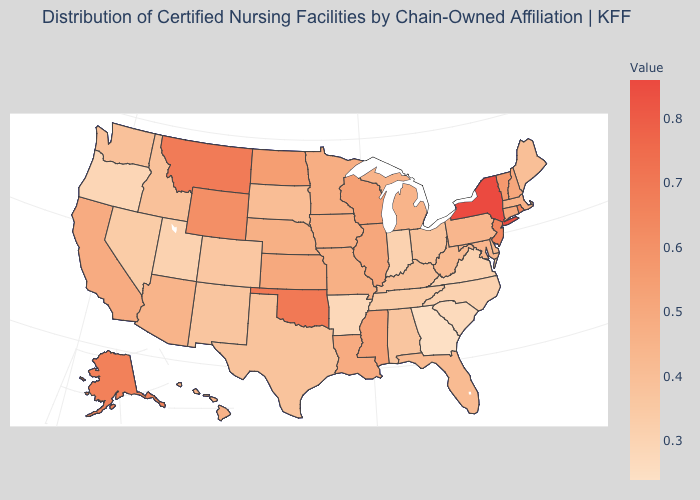Among the states that border Oklahoma , does Kansas have the highest value?
Answer briefly. Yes. Among the states that border Arizona , does California have the highest value?
Keep it brief. Yes. Among the states that border Illinois , does Wisconsin have the highest value?
Concise answer only. Yes. Among the states that border Kentucky , does Illinois have the highest value?
Give a very brief answer. Yes. Which states have the lowest value in the South?
Quick response, please. Georgia. Does the map have missing data?
Give a very brief answer. No. Does New York have the highest value in the Northeast?
Quick response, please. Yes. Which states have the lowest value in the MidWest?
Write a very short answer. Indiana. Among the states that border Wisconsin , which have the highest value?
Be succinct. Illinois. Does New York have the highest value in the USA?
Keep it brief. Yes. Does Georgia have the lowest value in the South?
Write a very short answer. Yes. 